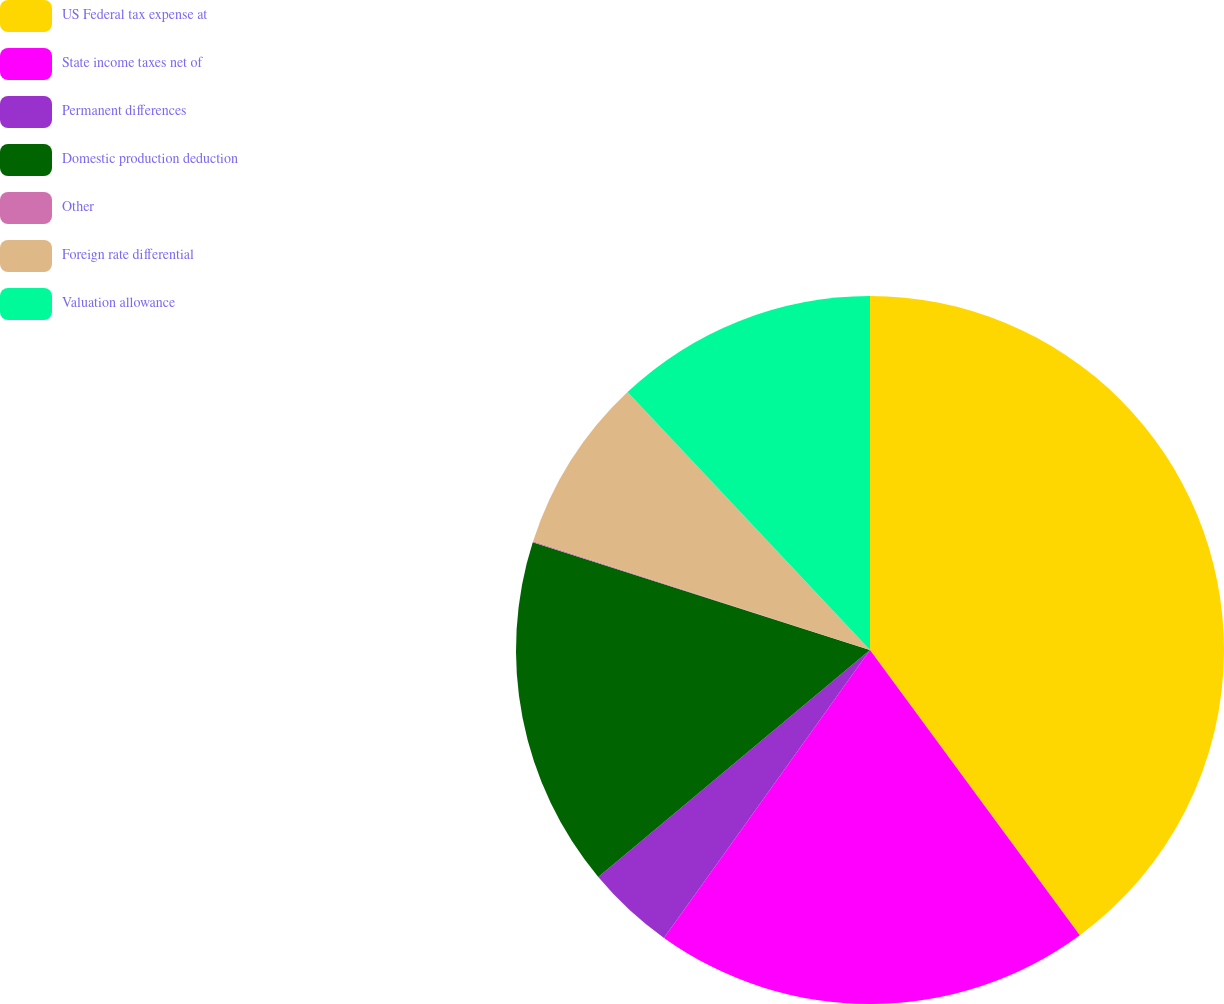<chart> <loc_0><loc_0><loc_500><loc_500><pie_chart><fcel>US Federal tax expense at<fcel>State income taxes net of<fcel>Permanent differences<fcel>Domestic production deduction<fcel>Other<fcel>Foreign rate differential<fcel>Valuation allowance<nl><fcel>39.9%<fcel>19.98%<fcel>4.04%<fcel>15.99%<fcel>0.05%<fcel>8.02%<fcel>12.01%<nl></chart> 